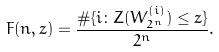Convert formula to latex. <formula><loc_0><loc_0><loc_500><loc_500>F ( n , z ) = \frac { \# \{ i \colon Z ( W _ { 2 ^ { n } } ^ { ( i ) } ) \leq z \} } { 2 ^ { n } } .</formula> 